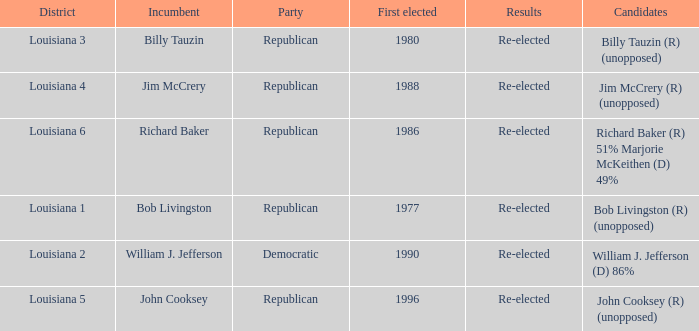What party does William J. Jefferson? Democratic. 